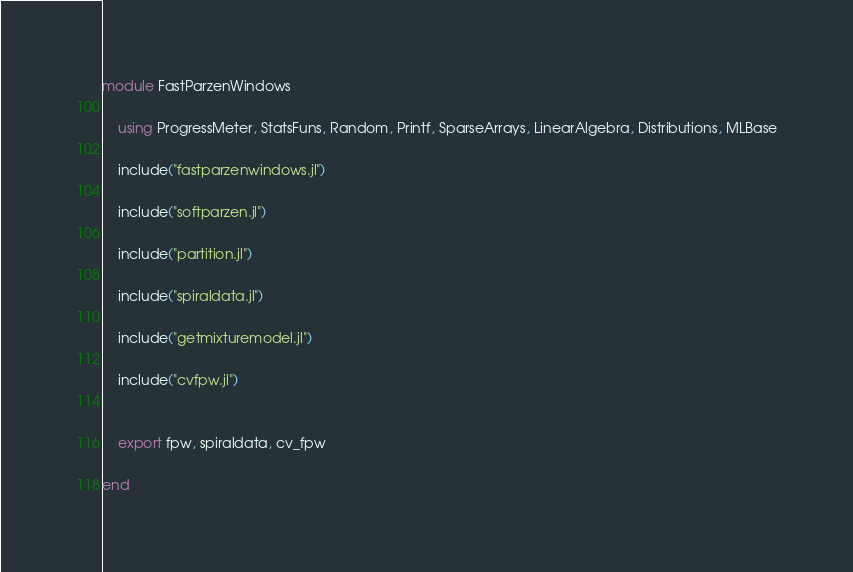Convert code to text. <code><loc_0><loc_0><loc_500><loc_500><_Julia_>module FastParzenWindows

    using ProgressMeter, StatsFuns, Random, Printf, SparseArrays, LinearAlgebra, Distributions, MLBase

    include("fastparzenwindows.jl")

    include("softparzen.jl")

    include("partition.jl")

    include("spiraldata.jl")

    include("getmixturemodel.jl")

    include("cvfpw.jl")


    export fpw, spiraldata, cv_fpw

end
</code> 